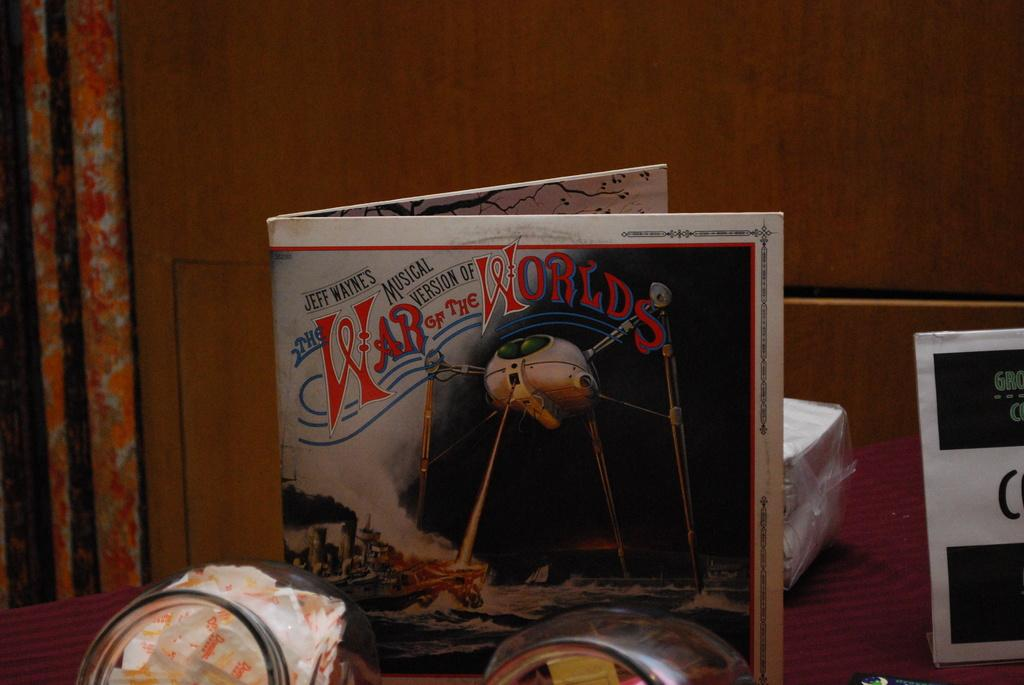Provide a one-sentence caption for the provided image. A War of the worlds paper standing upright on a table. 